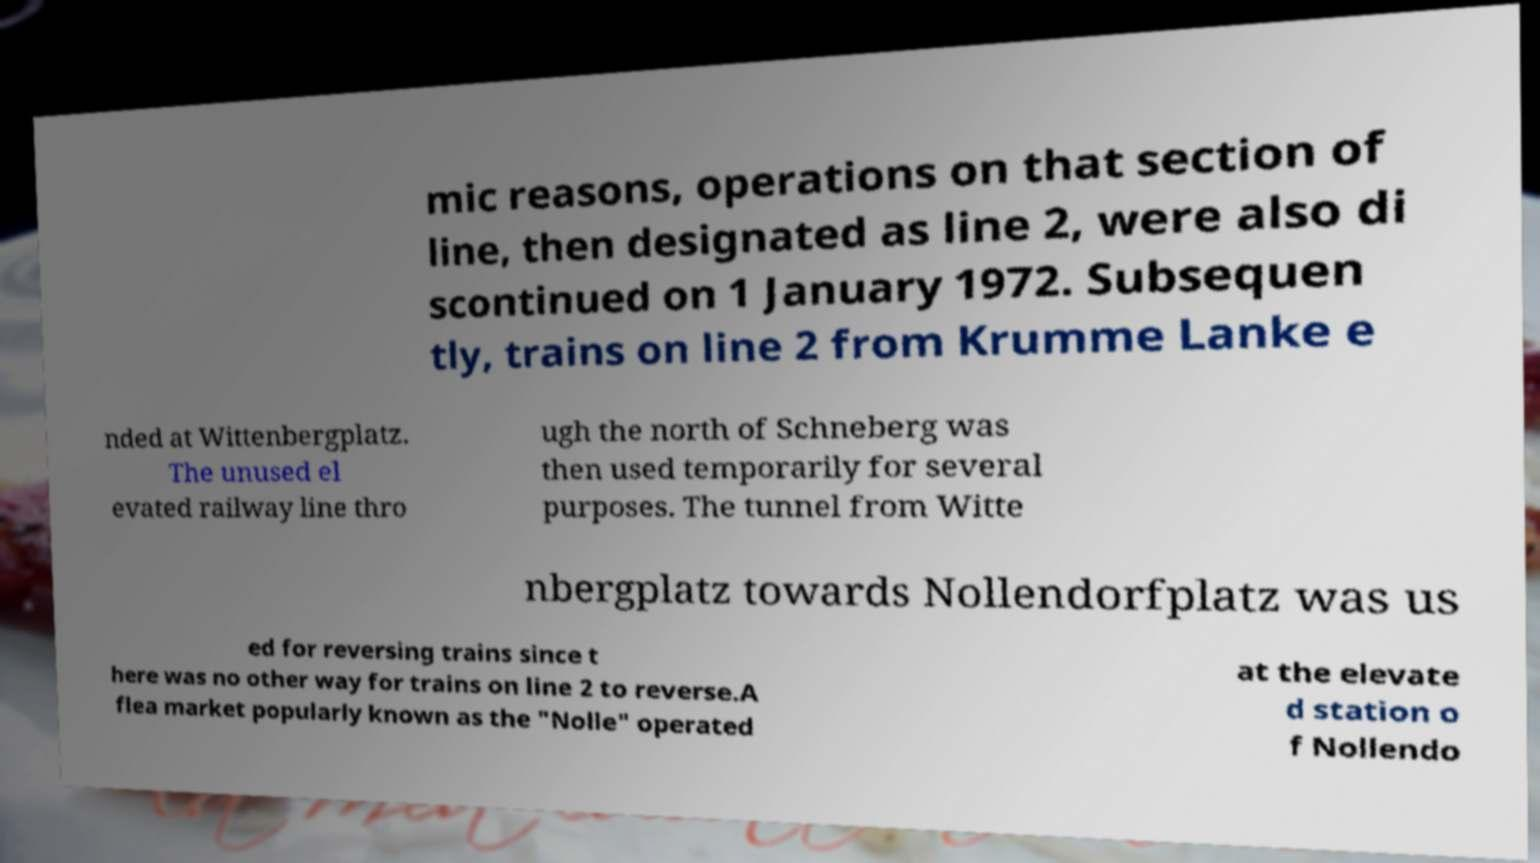Can you read and provide the text displayed in the image?This photo seems to have some interesting text. Can you extract and type it out for me? mic reasons, operations on that section of line, then designated as line 2, were also di scontinued on 1 January 1972. Subsequen tly, trains on line 2 from Krumme Lanke e nded at Wittenbergplatz. The unused el evated railway line thro ugh the north of Schneberg was then used temporarily for several purposes. The tunnel from Witte nbergplatz towards Nollendorfplatz was us ed for reversing trains since t here was no other way for trains on line 2 to reverse.A flea market popularly known as the "Nolle" operated at the elevate d station o f Nollendo 